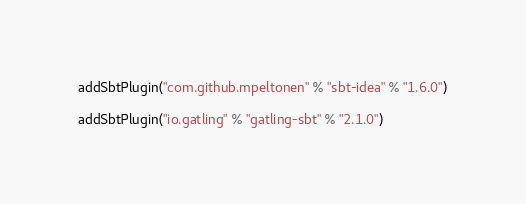Convert code to text. <code><loc_0><loc_0><loc_500><loc_500><_Scala_>
addSbtPlugin("com.github.mpeltonen" % "sbt-idea" % "1.6.0")

addSbtPlugin("io.gatling" % "gatling-sbt" % "2.1.0")</code> 